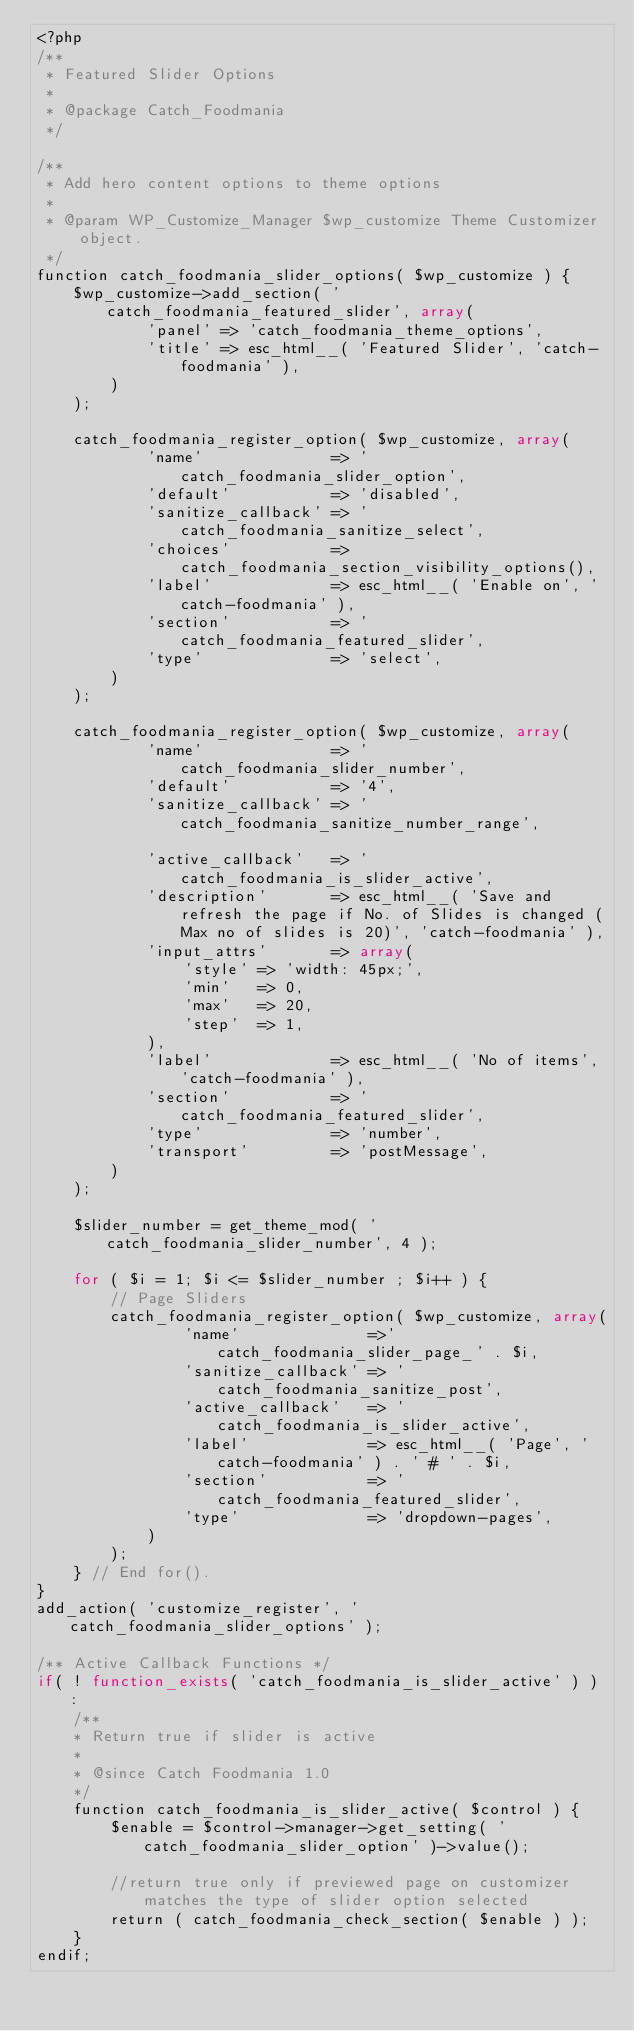Convert code to text. <code><loc_0><loc_0><loc_500><loc_500><_PHP_><?php
/**
 * Featured Slider Options
 *
 * @package Catch_Foodmania
 */

/**
 * Add hero content options to theme options
 *
 * @param WP_Customize_Manager $wp_customize Theme Customizer object.
 */
function catch_foodmania_slider_options( $wp_customize ) {
	$wp_customize->add_section( 'catch_foodmania_featured_slider', array(
			'panel' => 'catch_foodmania_theme_options',
			'title' => esc_html__( 'Featured Slider', 'catch-foodmania' ),
		)
	);

	catch_foodmania_register_option( $wp_customize, array(
			'name'              => 'catch_foodmania_slider_option',
			'default'           => 'disabled',
			'sanitize_callback' => 'catch_foodmania_sanitize_select',
			'choices'           => catch_foodmania_section_visibility_options(),
			'label'             => esc_html__( 'Enable on', 'catch-foodmania' ),
			'section'           => 'catch_foodmania_featured_slider',
			'type'              => 'select',
		)
	);

	catch_foodmania_register_option( $wp_customize, array(
			'name'              => 'catch_foodmania_slider_number',
			'default'           => '4',
			'sanitize_callback' => 'catch_foodmania_sanitize_number_range',

			'active_callback'   => 'catch_foodmania_is_slider_active',
			'description'       => esc_html__( 'Save and refresh the page if No. of Slides is changed (Max no of slides is 20)', 'catch-foodmania' ),
			'input_attrs'       => array(
				'style' => 'width: 45px;',
				'min'   => 0,
				'max'   => 20,
				'step'  => 1,
			),
			'label'             => esc_html__( 'No of items', 'catch-foodmania' ),
			'section'           => 'catch_foodmania_featured_slider',
			'type'              => 'number',
			'transport'         => 'postMessage',
		)
	);

	$slider_number = get_theme_mod( 'catch_foodmania_slider_number', 4 );

	for ( $i = 1; $i <= $slider_number ; $i++ ) {
		// Page Sliders
		catch_foodmania_register_option( $wp_customize, array(
				'name'              =>'catch_foodmania_slider_page_' . $i,
				'sanitize_callback' => 'catch_foodmania_sanitize_post',
				'active_callback'   => 'catch_foodmania_is_slider_active',
				'label'             => esc_html__( 'Page', 'catch-foodmania' ) . ' # ' . $i,
				'section'           => 'catch_foodmania_featured_slider',
				'type'              => 'dropdown-pages',
			)
		);
	} // End for().
}
add_action( 'customize_register', 'catch_foodmania_slider_options' );

/** Active Callback Functions */
if( ! function_exists( 'catch_foodmania_is_slider_active' ) ) :
	/**
	* Return true if slider is active
	*
	* @since Catch Foodmania 1.0
	*/
	function catch_foodmania_is_slider_active( $control ) {
		$enable = $control->manager->get_setting( 'catch_foodmania_slider_option' )->value();

		//return true only if previewed page on customizer matches the type of slider option selected
		return ( catch_foodmania_check_section( $enable ) );
	}
endif;</code> 